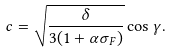Convert formula to latex. <formula><loc_0><loc_0><loc_500><loc_500>c = \sqrt { \frac { \delta } { { 3 ( 1 + \alpha { \sigma _ { F } } ) } } } \cos \gamma .</formula> 